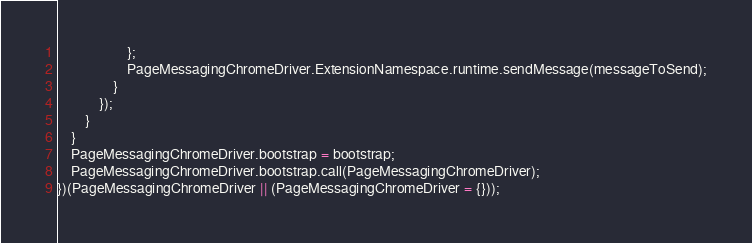<code> <loc_0><loc_0><loc_500><loc_500><_JavaScript_>                    };
                    PageMessagingChromeDriver.ExtensionNamespace.runtime.sendMessage(messageToSend);
                }
            });
        }
    }
    PageMessagingChromeDriver.bootstrap = bootstrap;
    PageMessagingChromeDriver.bootstrap.call(PageMessagingChromeDriver);
})(PageMessagingChromeDriver || (PageMessagingChromeDriver = {}));
</code> 